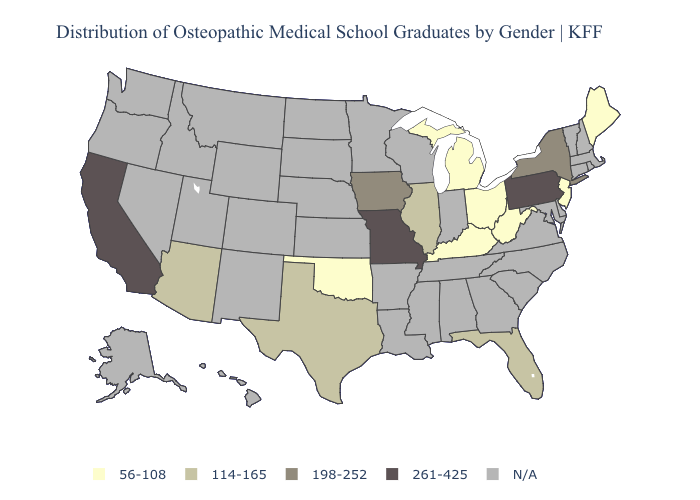Does the map have missing data?
Give a very brief answer. Yes. Which states hav the highest value in the South?
Quick response, please. Florida, Texas. Name the states that have a value in the range 198-252?
Short answer required. Iowa, New York. What is the highest value in states that border Colorado?
Write a very short answer. 114-165. What is the lowest value in the Northeast?
Write a very short answer. 56-108. Does the map have missing data?
Concise answer only. Yes. What is the value of North Carolina?
Quick response, please. N/A. Name the states that have a value in the range 261-425?
Be succinct. California, Missouri, Pennsylvania. Among the states that border Minnesota , which have the highest value?
Keep it brief. Iowa. Does the first symbol in the legend represent the smallest category?
Concise answer only. Yes. Which states have the highest value in the USA?
Give a very brief answer. California, Missouri, Pennsylvania. What is the value of Georgia?
Be succinct. N/A. What is the lowest value in the USA?
Concise answer only. 56-108. 